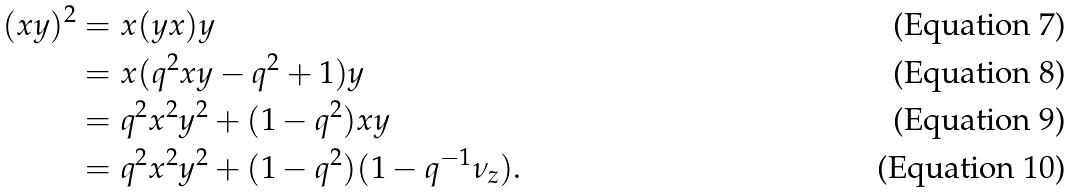<formula> <loc_0><loc_0><loc_500><loc_500>( x y ) ^ { 2 } & = x ( y x ) y \\ & = x ( q ^ { 2 } x y - q ^ { 2 } + 1 ) y \\ & = q ^ { 2 } x ^ { 2 } y ^ { 2 } + ( 1 - q ^ { 2 } ) x y \\ & = q ^ { 2 } x ^ { 2 } y ^ { 2 } + ( 1 - q ^ { 2 } ) ( 1 - q ^ { - 1 } \nu _ { z } ) .</formula> 